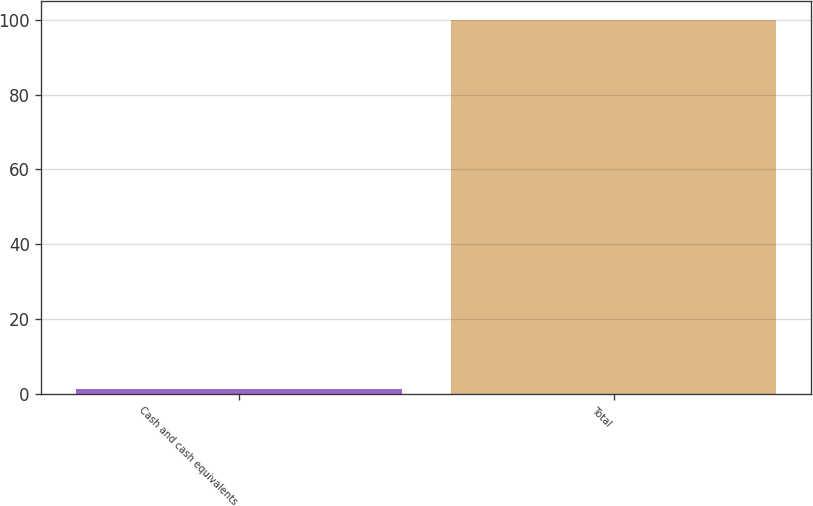<chart> <loc_0><loc_0><loc_500><loc_500><bar_chart><fcel>Cash and cash equivalents<fcel>Total<nl><fcel>1.2<fcel>100<nl></chart> 